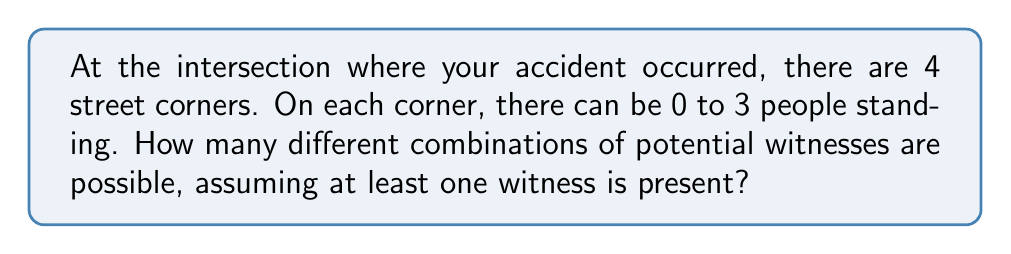Provide a solution to this math problem. Let's approach this step-by-step:

1) First, we need to understand that this is a combination with repetition problem. We have 4 corners, and each corner can have 0, 1, 2, or 3 people.

2) The total number of combinations, including the case where no one is present, would be $4^4 = 256$. This is because for each of the 4 corners, we have 4 choices.

3) However, we need to exclude the case where no one is present. That's only one combination: (0,0,0,0).

4) So, the number of combinations with at least one witness is:

   $256 - 1 = 255$

5) We can also calculate this using the formula for combinations with repetition:

   $$\binom{n+r-1}{r} = \binom{4+4-1}{4} = \binom{7}{4} = 35$$

   Where $n$ is the number of types (4 corners) and $r$ is the number of items to choose (4 people).

6) However, this gives us the number of ways to distribute exactly 4 people. We need to sum this for 1, 2, 3, and 4 people:

   $$\binom{7}{1} + \binom{7}{2} + \binom{7}{3} + \binom{7}{4} = 7 + 21 + 35 + 35 = 98$$

7) But this doesn't account for having more than 4 people. The total from step 4 is correct.
Answer: 255 